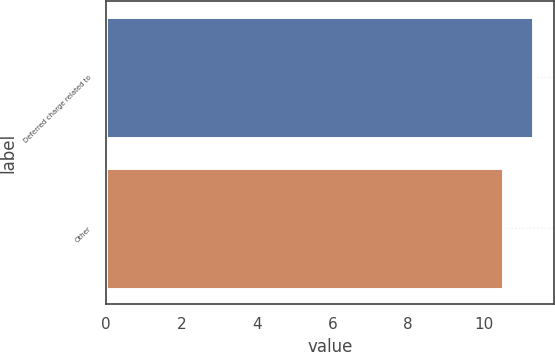<chart> <loc_0><loc_0><loc_500><loc_500><bar_chart><fcel>Deferred charge related to<fcel>Other<nl><fcel>11.3<fcel>10.5<nl></chart> 